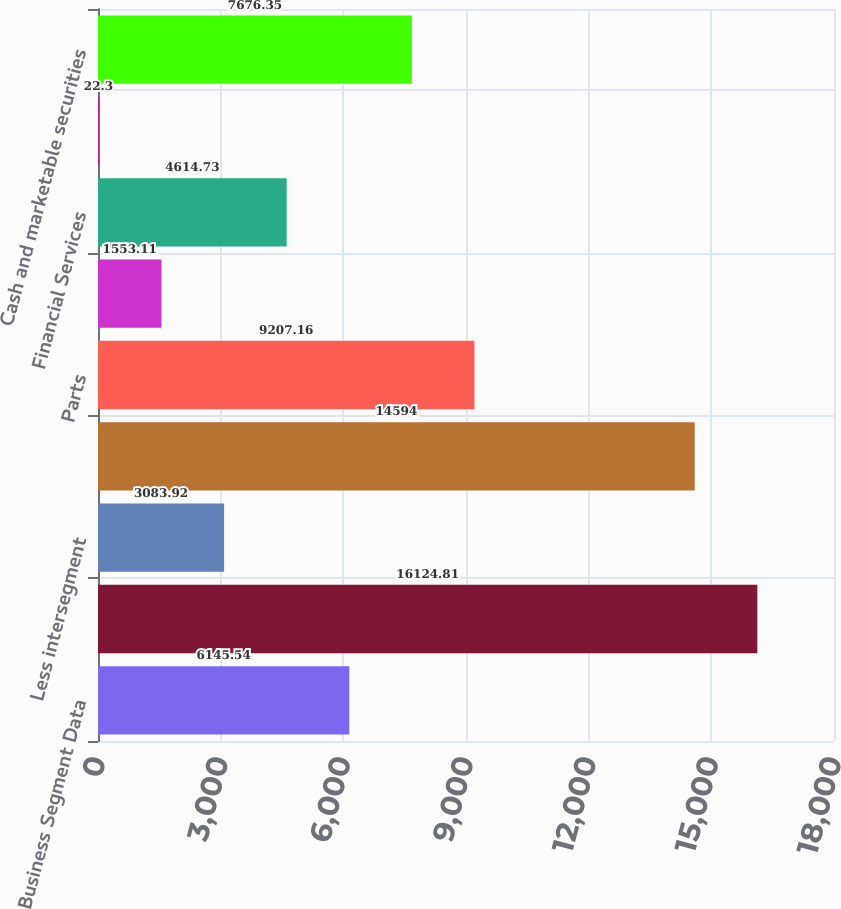Convert chart to OTSL. <chart><loc_0><loc_0><loc_500><loc_500><bar_chart><fcel>Business Segment Data<fcel>Truck<fcel>Less intersegment<fcel>External customers<fcel>Parts<fcel>Other<fcel>Financial Services<fcel>Investment income<fcel>Cash and marketable securities<nl><fcel>6145.54<fcel>16124.8<fcel>3083.92<fcel>14594<fcel>9207.16<fcel>1553.11<fcel>4614.73<fcel>22.3<fcel>7676.35<nl></chart> 